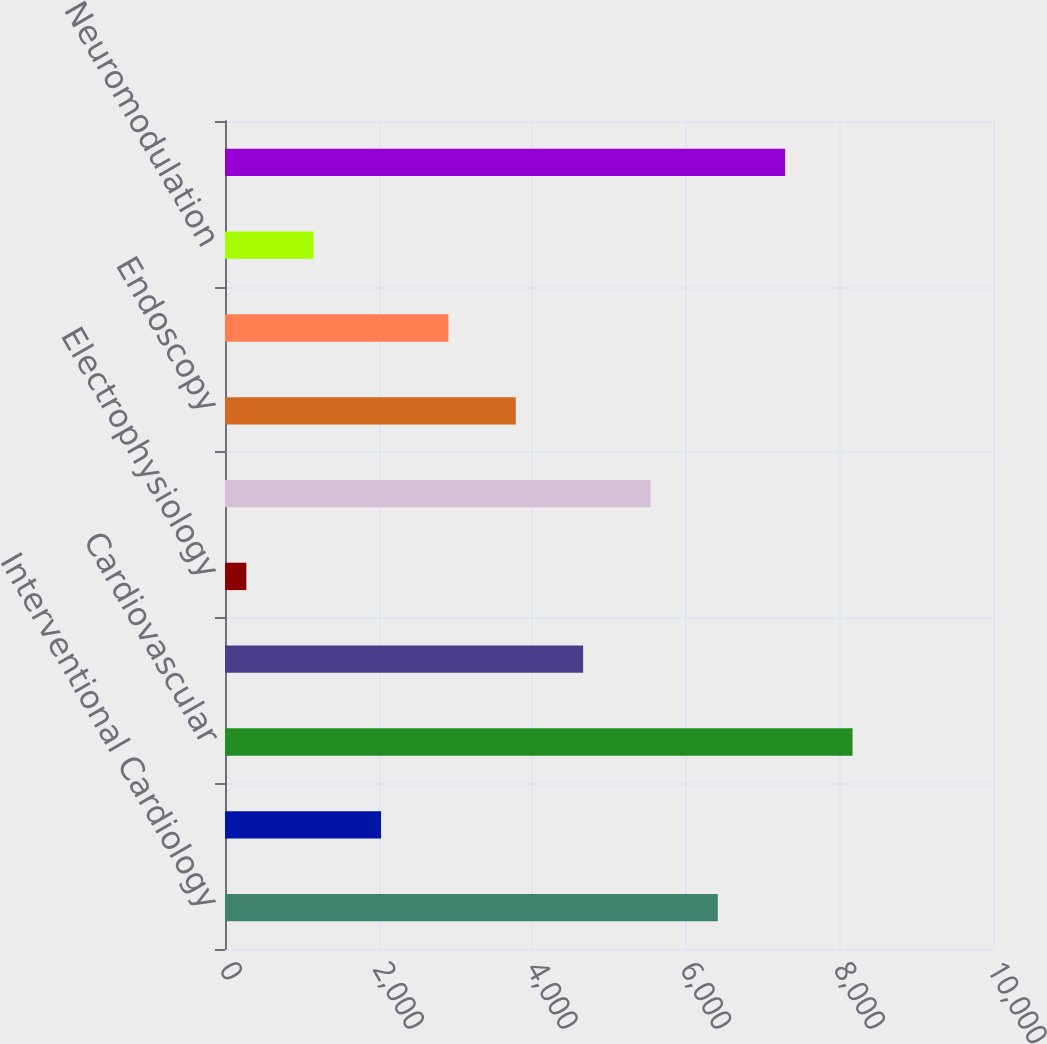<chart> <loc_0><loc_0><loc_500><loc_500><bar_chart><fcel>Interventional Cardiology<fcel>Peripheral Interventions<fcel>Cardiovascular<fcel>Cardiac Rhythm Management<fcel>Electrophysiology<fcel>Rhythm Management<fcel>Endoscopy<fcel>Urology and Pelvic Health<fcel>Neuromodulation<fcel>MedSurg<nl><fcel>6417<fcel>2032<fcel>8171<fcel>4663<fcel>278<fcel>5540<fcel>3786<fcel>2909<fcel>1155<fcel>7294<nl></chart> 